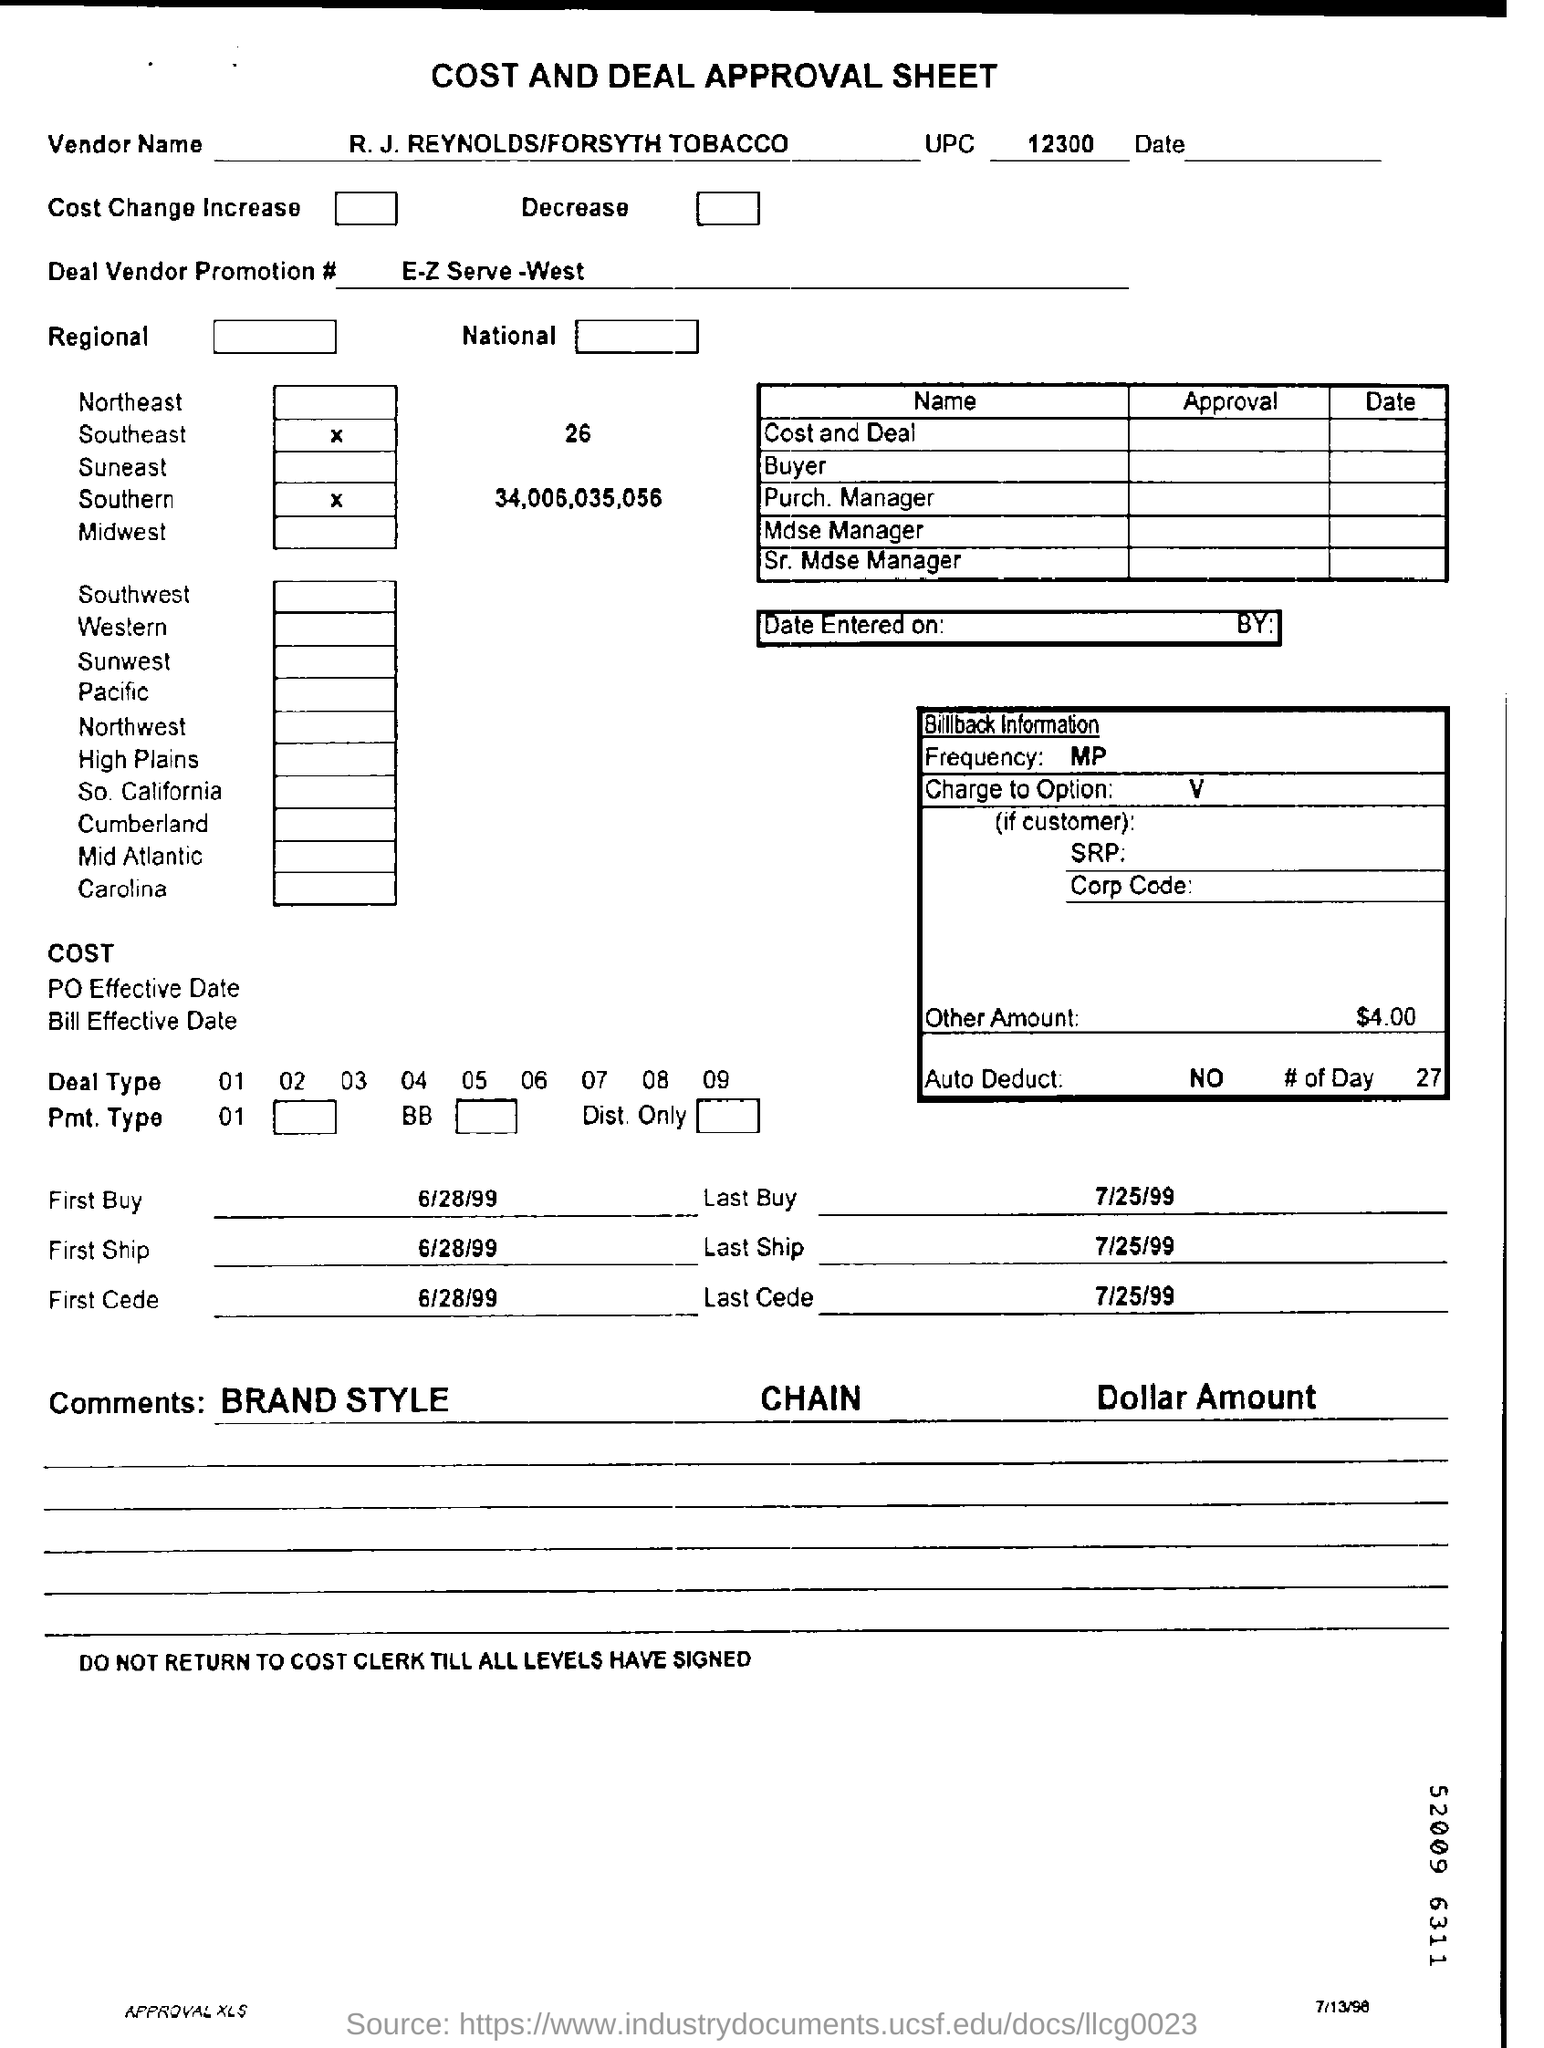Identify some key points in this picture. What is the deal for Vendor Promotion # E-Z Serve -West? The vendor name is R. J. REYNOLDS/FORSYTH TOBACCO. What is the UPC? It is a 12-digit numerical code that is assigned to products to identify them and track their sales. The UPC is commonly found on product packaging and is used in retail inventory management systems. The amount mentioned is $4.00. 